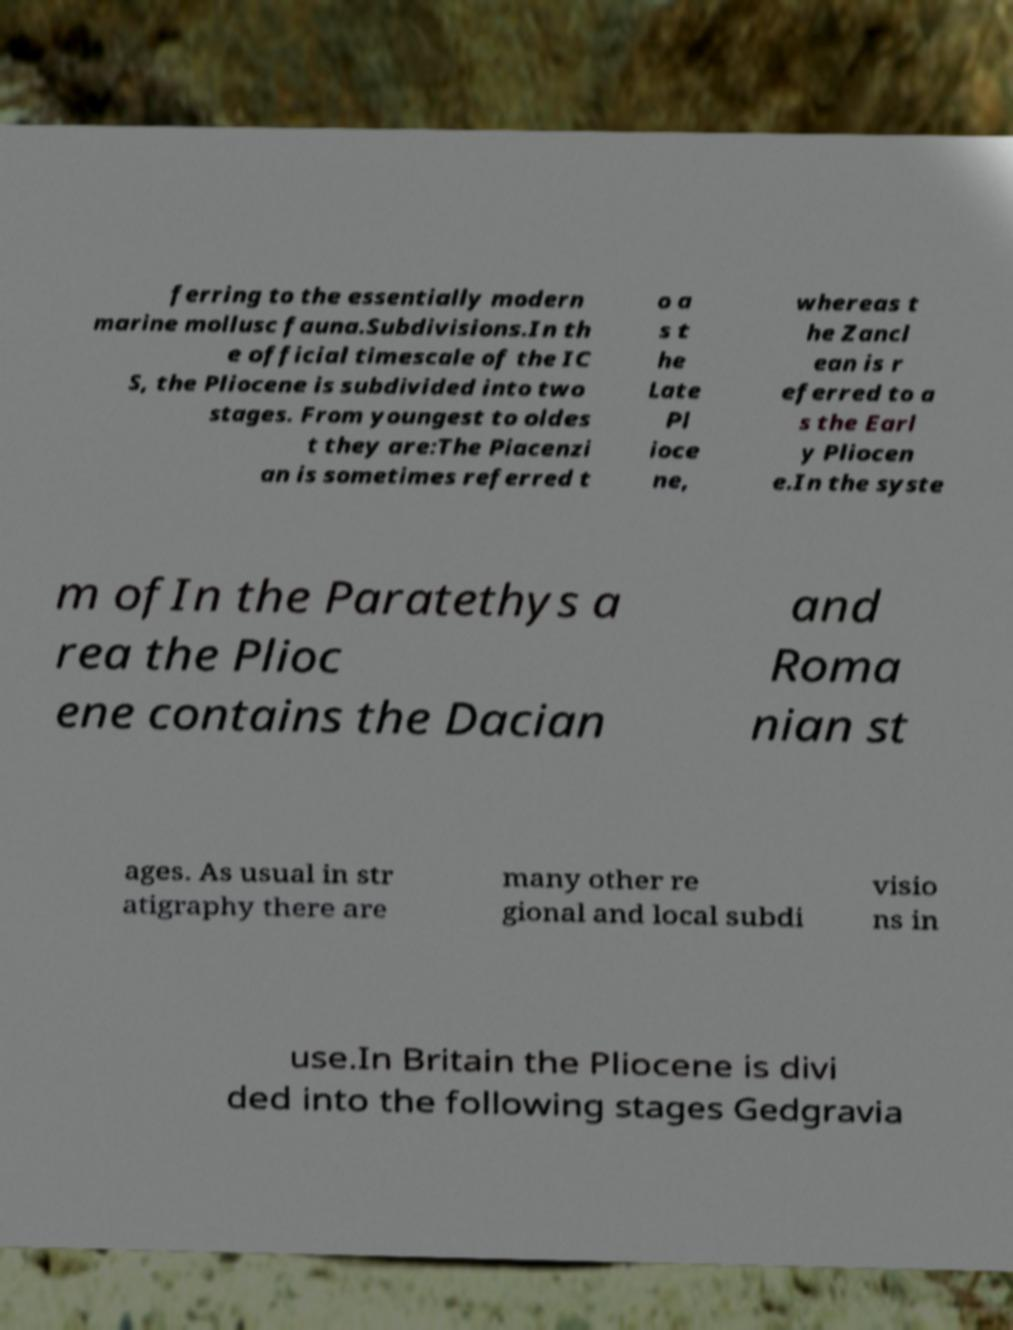There's text embedded in this image that I need extracted. Can you transcribe it verbatim? ferring to the essentially modern marine mollusc fauna.Subdivisions.In th e official timescale of the IC S, the Pliocene is subdivided into two stages. From youngest to oldes t they are:The Piacenzi an is sometimes referred t o a s t he Late Pl ioce ne, whereas t he Zancl ean is r eferred to a s the Earl y Pliocen e.In the syste m ofIn the Paratethys a rea the Plioc ene contains the Dacian and Roma nian st ages. As usual in str atigraphy there are many other re gional and local subdi visio ns in use.In Britain the Pliocene is divi ded into the following stages Gedgravia 